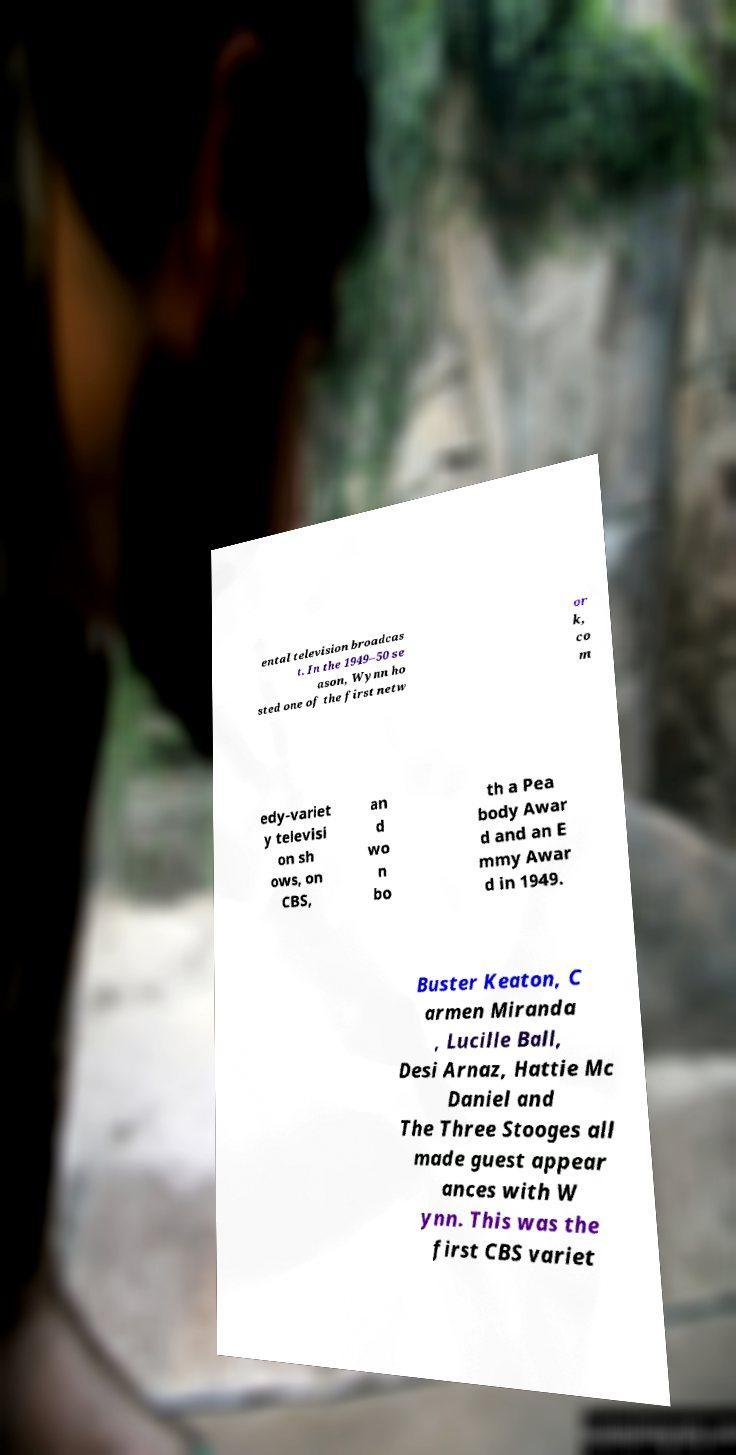Please read and relay the text visible in this image. What does it say? ental television broadcas t. In the 1949–50 se ason, Wynn ho sted one of the first netw or k, co m edy-variet y televisi on sh ows, on CBS, an d wo n bo th a Pea body Awar d and an E mmy Awar d in 1949. Buster Keaton, C armen Miranda , Lucille Ball, Desi Arnaz, Hattie Mc Daniel and The Three Stooges all made guest appear ances with W ynn. This was the first CBS variet 